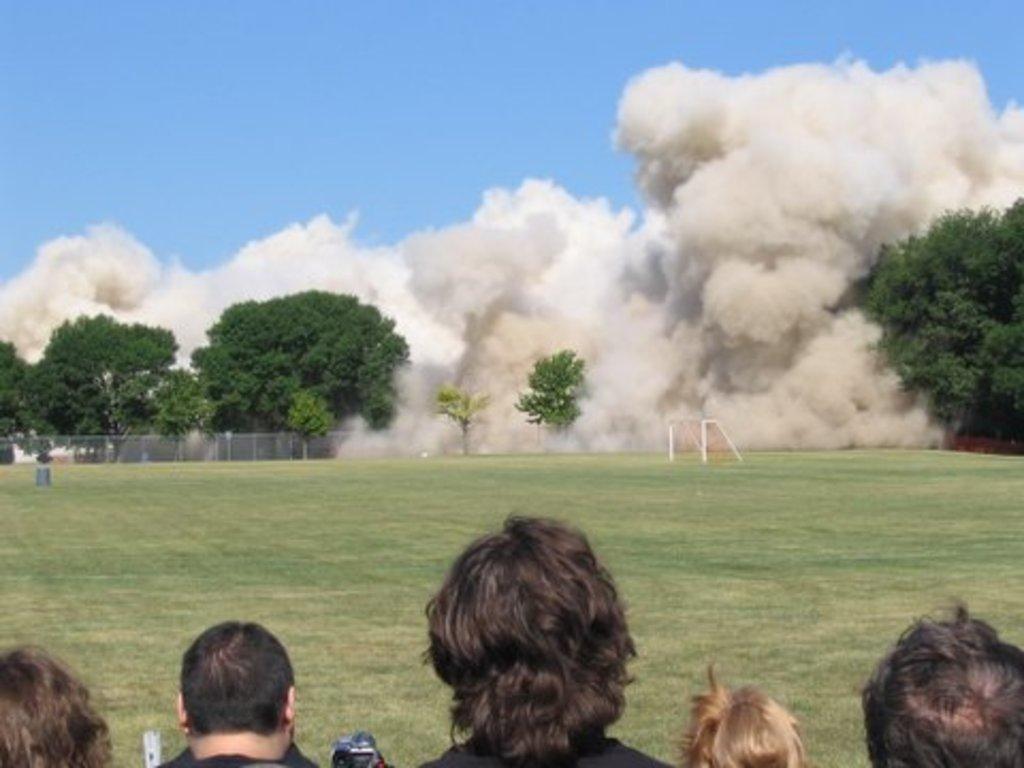Could you give a brief overview of what you see in this image? In this image, we can see people and in there are objects. In the background, there is a fence, stand, trees and we can see smoke. At the bottom, there is ground and at the top, there is sky. 